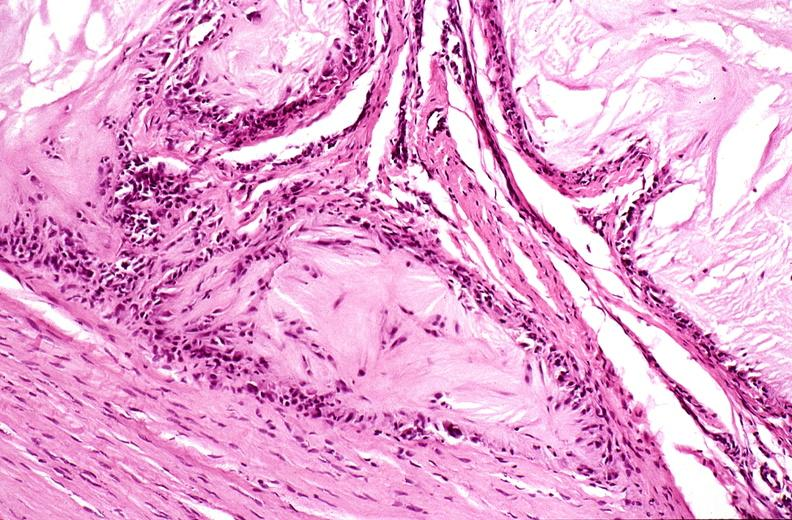does polycystic disease show gout?
Answer the question using a single word or phrase. No 